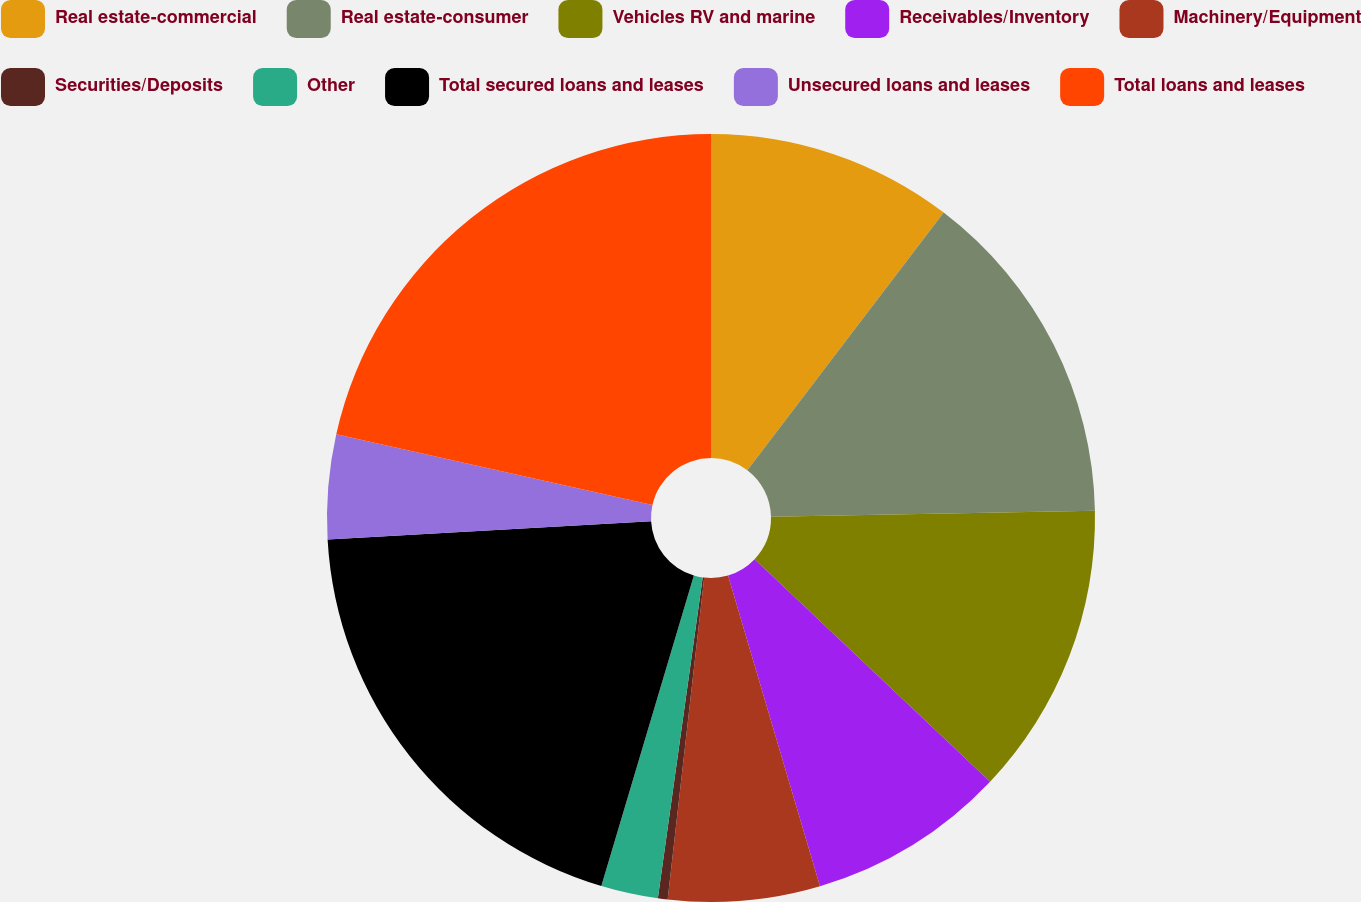Convert chart. <chart><loc_0><loc_0><loc_500><loc_500><pie_chart><fcel>Real estate-commercial<fcel>Real estate-consumer<fcel>Vehicles RV and marine<fcel>Receivables/Inventory<fcel>Machinery/Equipment<fcel>Securities/Deposits<fcel>Other<fcel>Total secured loans and leases<fcel>Unsecured loans and leases<fcel>Total loans and leases<nl><fcel>10.36%<fcel>14.34%<fcel>12.35%<fcel>8.37%<fcel>6.38%<fcel>0.41%<fcel>2.4%<fcel>19.5%<fcel>4.39%<fcel>21.5%<nl></chart> 